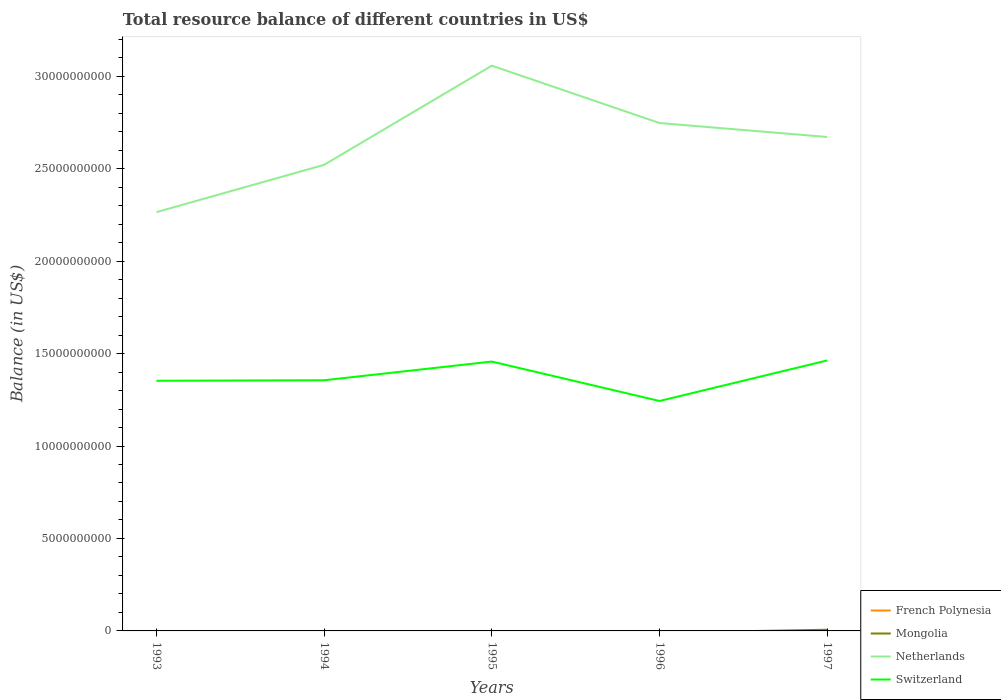Across all years, what is the maximum total resource balance in Netherlands?
Provide a succinct answer. 2.26e+1. What is the total total resource balance in Switzerland in the graph?
Provide a short and direct response. 2.13e+09. What is the difference between the highest and the second highest total resource balance in Netherlands?
Provide a succinct answer. 7.92e+09. What is the difference between the highest and the lowest total resource balance in Netherlands?
Provide a succinct answer. 3. Is the total resource balance in Mongolia strictly greater than the total resource balance in French Polynesia over the years?
Provide a short and direct response. No. How many lines are there?
Ensure brevity in your answer.  3. What is the difference between two consecutive major ticks on the Y-axis?
Your response must be concise. 5.00e+09. Are the values on the major ticks of Y-axis written in scientific E-notation?
Provide a short and direct response. No. Does the graph contain any zero values?
Your answer should be very brief. Yes. Where does the legend appear in the graph?
Your response must be concise. Bottom right. What is the title of the graph?
Keep it short and to the point. Total resource balance of different countries in US$. Does "Albania" appear as one of the legend labels in the graph?
Give a very brief answer. No. What is the label or title of the Y-axis?
Keep it short and to the point. Balance (in US$). What is the Balance (in US$) of French Polynesia in 1993?
Offer a terse response. 0. What is the Balance (in US$) in Netherlands in 1993?
Provide a short and direct response. 2.26e+1. What is the Balance (in US$) of Switzerland in 1993?
Give a very brief answer. 1.35e+1. What is the Balance (in US$) of Mongolia in 1994?
Provide a succinct answer. 0. What is the Balance (in US$) in Netherlands in 1994?
Your answer should be compact. 2.52e+1. What is the Balance (in US$) of Switzerland in 1994?
Give a very brief answer. 1.36e+1. What is the Balance (in US$) of French Polynesia in 1995?
Your response must be concise. 0. What is the Balance (in US$) in Mongolia in 1995?
Provide a succinct answer. 0. What is the Balance (in US$) in Netherlands in 1995?
Give a very brief answer. 3.06e+1. What is the Balance (in US$) of Switzerland in 1995?
Your answer should be very brief. 1.46e+1. What is the Balance (in US$) of French Polynesia in 1996?
Give a very brief answer. 0. What is the Balance (in US$) in Netherlands in 1996?
Give a very brief answer. 2.75e+1. What is the Balance (in US$) in Switzerland in 1996?
Provide a succinct answer. 1.24e+1. What is the Balance (in US$) of Mongolia in 1997?
Offer a very short reply. 6.31e+07. What is the Balance (in US$) in Netherlands in 1997?
Your response must be concise. 2.67e+1. What is the Balance (in US$) of Switzerland in 1997?
Provide a succinct answer. 1.46e+1. Across all years, what is the maximum Balance (in US$) in Mongolia?
Offer a terse response. 6.31e+07. Across all years, what is the maximum Balance (in US$) of Netherlands?
Your answer should be very brief. 3.06e+1. Across all years, what is the maximum Balance (in US$) of Switzerland?
Give a very brief answer. 1.46e+1. Across all years, what is the minimum Balance (in US$) of Netherlands?
Your answer should be very brief. 2.26e+1. Across all years, what is the minimum Balance (in US$) in Switzerland?
Provide a short and direct response. 1.24e+1. What is the total Balance (in US$) of Mongolia in the graph?
Provide a short and direct response. 6.31e+07. What is the total Balance (in US$) in Netherlands in the graph?
Your response must be concise. 1.33e+11. What is the total Balance (in US$) of Switzerland in the graph?
Ensure brevity in your answer.  6.87e+1. What is the difference between the Balance (in US$) in Netherlands in 1993 and that in 1994?
Give a very brief answer. -2.56e+09. What is the difference between the Balance (in US$) in Switzerland in 1993 and that in 1994?
Make the answer very short. -2.77e+07. What is the difference between the Balance (in US$) of Netherlands in 1993 and that in 1995?
Provide a succinct answer. -7.92e+09. What is the difference between the Balance (in US$) in Switzerland in 1993 and that in 1995?
Your response must be concise. -1.04e+09. What is the difference between the Balance (in US$) of Netherlands in 1993 and that in 1996?
Your answer should be very brief. -4.82e+09. What is the difference between the Balance (in US$) of Switzerland in 1993 and that in 1996?
Your response must be concise. 1.09e+09. What is the difference between the Balance (in US$) of Netherlands in 1993 and that in 1997?
Make the answer very short. -4.07e+09. What is the difference between the Balance (in US$) in Switzerland in 1993 and that in 1997?
Keep it short and to the point. -1.10e+09. What is the difference between the Balance (in US$) in Netherlands in 1994 and that in 1995?
Give a very brief answer. -5.36e+09. What is the difference between the Balance (in US$) in Switzerland in 1994 and that in 1995?
Offer a terse response. -1.01e+09. What is the difference between the Balance (in US$) in Netherlands in 1994 and that in 1996?
Give a very brief answer. -2.26e+09. What is the difference between the Balance (in US$) of Switzerland in 1994 and that in 1996?
Your answer should be compact. 1.12e+09. What is the difference between the Balance (in US$) in Netherlands in 1994 and that in 1997?
Your response must be concise. -1.51e+09. What is the difference between the Balance (in US$) of Switzerland in 1994 and that in 1997?
Provide a succinct answer. -1.07e+09. What is the difference between the Balance (in US$) in Netherlands in 1995 and that in 1996?
Offer a terse response. 3.10e+09. What is the difference between the Balance (in US$) in Switzerland in 1995 and that in 1996?
Offer a very short reply. 2.13e+09. What is the difference between the Balance (in US$) in Netherlands in 1995 and that in 1997?
Provide a succinct answer. 3.86e+09. What is the difference between the Balance (in US$) of Switzerland in 1995 and that in 1997?
Offer a terse response. -6.14e+07. What is the difference between the Balance (in US$) of Netherlands in 1996 and that in 1997?
Your answer should be very brief. 7.54e+08. What is the difference between the Balance (in US$) in Switzerland in 1996 and that in 1997?
Offer a very short reply. -2.19e+09. What is the difference between the Balance (in US$) in Netherlands in 1993 and the Balance (in US$) in Switzerland in 1994?
Give a very brief answer. 9.09e+09. What is the difference between the Balance (in US$) of Netherlands in 1993 and the Balance (in US$) of Switzerland in 1995?
Ensure brevity in your answer.  8.08e+09. What is the difference between the Balance (in US$) of Netherlands in 1993 and the Balance (in US$) of Switzerland in 1996?
Your response must be concise. 1.02e+1. What is the difference between the Balance (in US$) of Netherlands in 1993 and the Balance (in US$) of Switzerland in 1997?
Offer a very short reply. 8.02e+09. What is the difference between the Balance (in US$) of Netherlands in 1994 and the Balance (in US$) of Switzerland in 1995?
Offer a terse response. 1.06e+1. What is the difference between the Balance (in US$) of Netherlands in 1994 and the Balance (in US$) of Switzerland in 1996?
Offer a terse response. 1.28e+1. What is the difference between the Balance (in US$) in Netherlands in 1994 and the Balance (in US$) in Switzerland in 1997?
Ensure brevity in your answer.  1.06e+1. What is the difference between the Balance (in US$) of Netherlands in 1995 and the Balance (in US$) of Switzerland in 1996?
Provide a succinct answer. 1.81e+1. What is the difference between the Balance (in US$) of Netherlands in 1995 and the Balance (in US$) of Switzerland in 1997?
Provide a short and direct response. 1.59e+1. What is the difference between the Balance (in US$) of Netherlands in 1996 and the Balance (in US$) of Switzerland in 1997?
Offer a terse response. 1.28e+1. What is the average Balance (in US$) of French Polynesia per year?
Make the answer very short. 0. What is the average Balance (in US$) of Mongolia per year?
Offer a very short reply. 1.26e+07. What is the average Balance (in US$) in Netherlands per year?
Offer a very short reply. 2.65e+1. What is the average Balance (in US$) in Switzerland per year?
Ensure brevity in your answer.  1.37e+1. In the year 1993, what is the difference between the Balance (in US$) in Netherlands and Balance (in US$) in Switzerland?
Give a very brief answer. 9.12e+09. In the year 1994, what is the difference between the Balance (in US$) of Netherlands and Balance (in US$) of Switzerland?
Your response must be concise. 1.16e+1. In the year 1995, what is the difference between the Balance (in US$) of Netherlands and Balance (in US$) of Switzerland?
Your response must be concise. 1.60e+1. In the year 1996, what is the difference between the Balance (in US$) in Netherlands and Balance (in US$) in Switzerland?
Your answer should be compact. 1.50e+1. In the year 1997, what is the difference between the Balance (in US$) of Mongolia and Balance (in US$) of Netherlands?
Ensure brevity in your answer.  -2.66e+1. In the year 1997, what is the difference between the Balance (in US$) of Mongolia and Balance (in US$) of Switzerland?
Offer a terse response. -1.46e+1. In the year 1997, what is the difference between the Balance (in US$) in Netherlands and Balance (in US$) in Switzerland?
Give a very brief answer. 1.21e+1. What is the ratio of the Balance (in US$) in Netherlands in 1993 to that in 1994?
Offer a very short reply. 0.9. What is the ratio of the Balance (in US$) in Netherlands in 1993 to that in 1995?
Offer a terse response. 0.74. What is the ratio of the Balance (in US$) of Switzerland in 1993 to that in 1995?
Give a very brief answer. 0.93. What is the ratio of the Balance (in US$) of Netherlands in 1993 to that in 1996?
Provide a short and direct response. 0.82. What is the ratio of the Balance (in US$) of Switzerland in 1993 to that in 1996?
Your answer should be very brief. 1.09. What is the ratio of the Balance (in US$) in Netherlands in 1993 to that in 1997?
Make the answer very short. 0.85. What is the ratio of the Balance (in US$) in Switzerland in 1993 to that in 1997?
Keep it short and to the point. 0.92. What is the ratio of the Balance (in US$) of Netherlands in 1994 to that in 1995?
Give a very brief answer. 0.82. What is the ratio of the Balance (in US$) in Switzerland in 1994 to that in 1995?
Give a very brief answer. 0.93. What is the ratio of the Balance (in US$) in Netherlands in 1994 to that in 1996?
Keep it short and to the point. 0.92. What is the ratio of the Balance (in US$) in Switzerland in 1994 to that in 1996?
Make the answer very short. 1.09. What is the ratio of the Balance (in US$) in Netherlands in 1994 to that in 1997?
Provide a succinct answer. 0.94. What is the ratio of the Balance (in US$) of Switzerland in 1994 to that in 1997?
Provide a short and direct response. 0.93. What is the ratio of the Balance (in US$) in Netherlands in 1995 to that in 1996?
Make the answer very short. 1.11. What is the ratio of the Balance (in US$) in Switzerland in 1995 to that in 1996?
Offer a terse response. 1.17. What is the ratio of the Balance (in US$) in Netherlands in 1995 to that in 1997?
Ensure brevity in your answer.  1.14. What is the ratio of the Balance (in US$) of Switzerland in 1995 to that in 1997?
Provide a short and direct response. 1. What is the ratio of the Balance (in US$) of Netherlands in 1996 to that in 1997?
Make the answer very short. 1.03. What is the ratio of the Balance (in US$) in Switzerland in 1996 to that in 1997?
Provide a succinct answer. 0.85. What is the difference between the highest and the second highest Balance (in US$) in Netherlands?
Offer a terse response. 3.10e+09. What is the difference between the highest and the second highest Balance (in US$) in Switzerland?
Provide a succinct answer. 6.14e+07. What is the difference between the highest and the lowest Balance (in US$) of Mongolia?
Keep it short and to the point. 6.31e+07. What is the difference between the highest and the lowest Balance (in US$) of Netherlands?
Offer a terse response. 7.92e+09. What is the difference between the highest and the lowest Balance (in US$) in Switzerland?
Provide a succinct answer. 2.19e+09. 